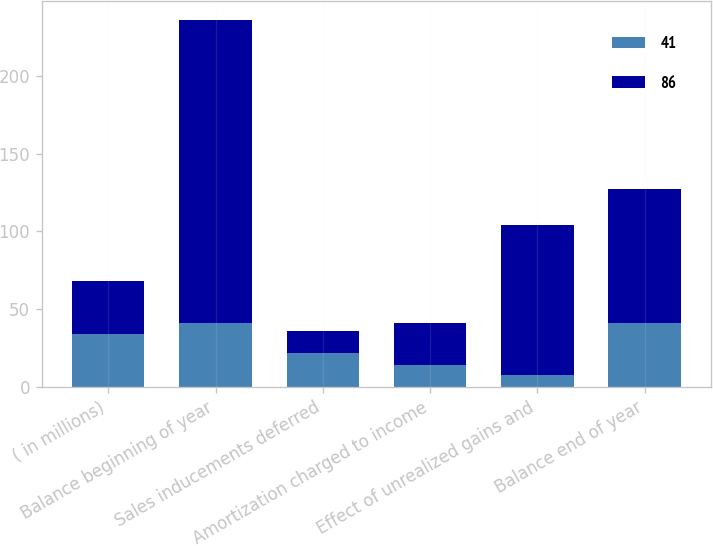<chart> <loc_0><loc_0><loc_500><loc_500><stacked_bar_chart><ecel><fcel>( in millions)<fcel>Balance beginning of year<fcel>Sales inducements deferred<fcel>Amortization charged to income<fcel>Effect of unrealized gains and<fcel>Balance end of year<nl><fcel>41<fcel>34<fcel>41<fcel>22<fcel>14<fcel>8<fcel>41<nl><fcel>86<fcel>34<fcel>195<fcel>14<fcel>27<fcel>96<fcel>86<nl></chart> 